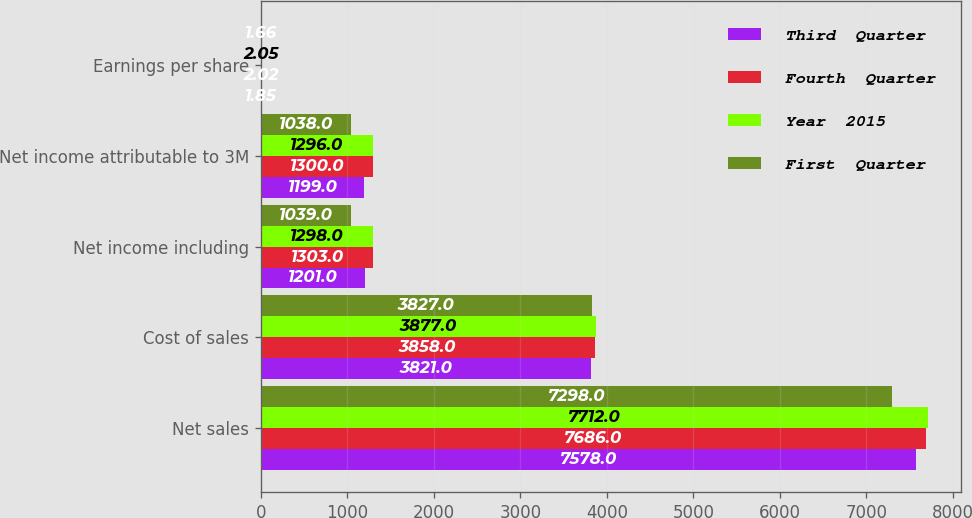Convert chart to OTSL. <chart><loc_0><loc_0><loc_500><loc_500><stacked_bar_chart><ecel><fcel>Net sales<fcel>Cost of sales<fcel>Net income including<fcel>Net income attributable to 3M<fcel>Earnings per share<nl><fcel>Third  Quarter<fcel>7578<fcel>3821<fcel>1201<fcel>1199<fcel>1.85<nl><fcel>Fourth  Quarter<fcel>7686<fcel>3858<fcel>1303<fcel>1300<fcel>2.02<nl><fcel>Year  2015<fcel>7712<fcel>3877<fcel>1298<fcel>1296<fcel>2.05<nl><fcel>First  Quarter<fcel>7298<fcel>3827<fcel>1039<fcel>1038<fcel>1.66<nl></chart> 